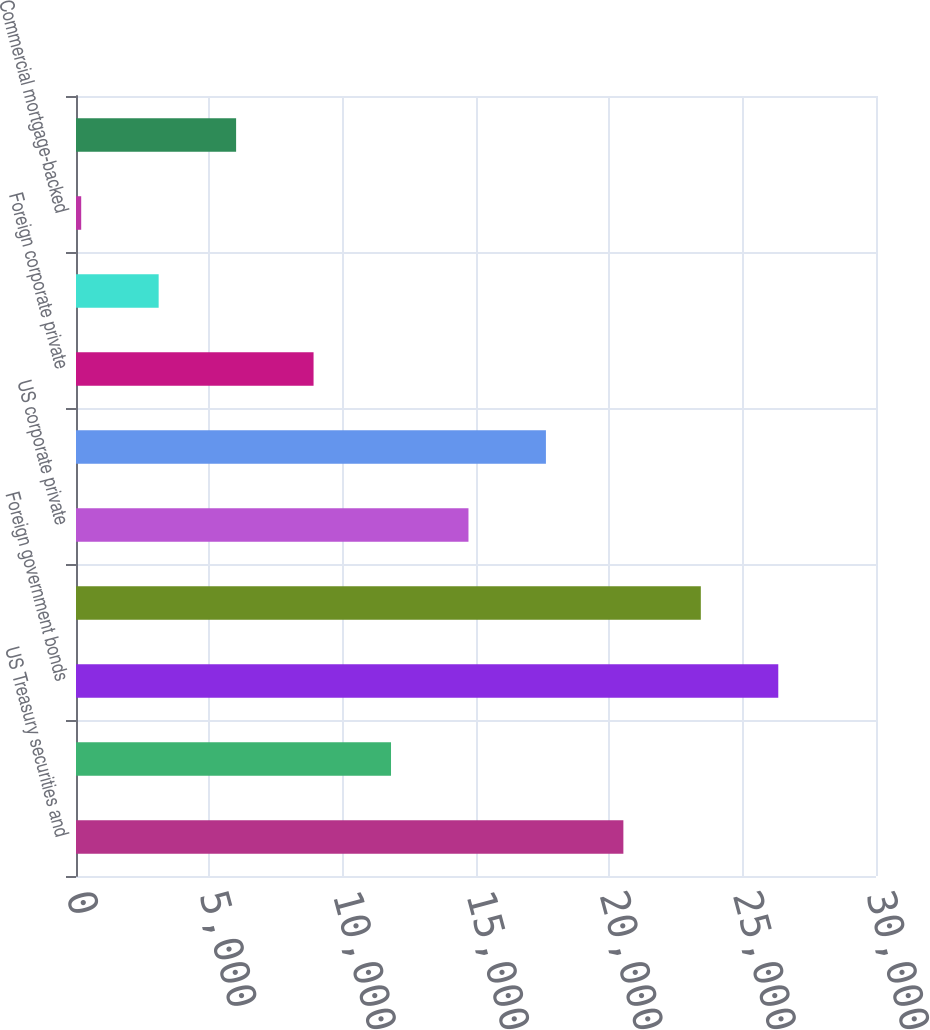Convert chart. <chart><loc_0><loc_0><loc_500><loc_500><bar_chart><fcel>US Treasury securities and<fcel>Obligations of US states and<fcel>Foreign government bonds<fcel>US corporate public securities<fcel>US corporate private<fcel>Foreign corporate public<fcel>Foreign corporate private<fcel>Asset-backed securities(2)<fcel>Commercial mortgage-backed<fcel>Residential mortgage-backed<nl><fcel>20526.5<fcel>11813<fcel>26335.5<fcel>23431<fcel>14717.5<fcel>17622<fcel>8908.5<fcel>3099.5<fcel>195<fcel>6004<nl></chart> 